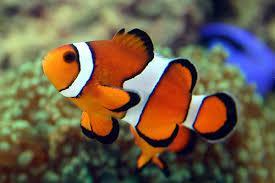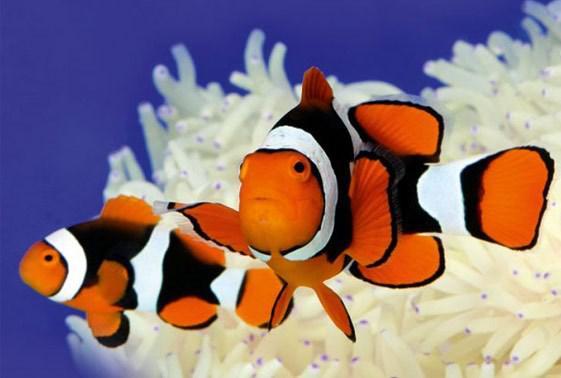The first image is the image on the left, the second image is the image on the right. For the images shown, is this caption "The images show a total of two orange-faced fish swimming rightward." true? Answer yes or no. No. 